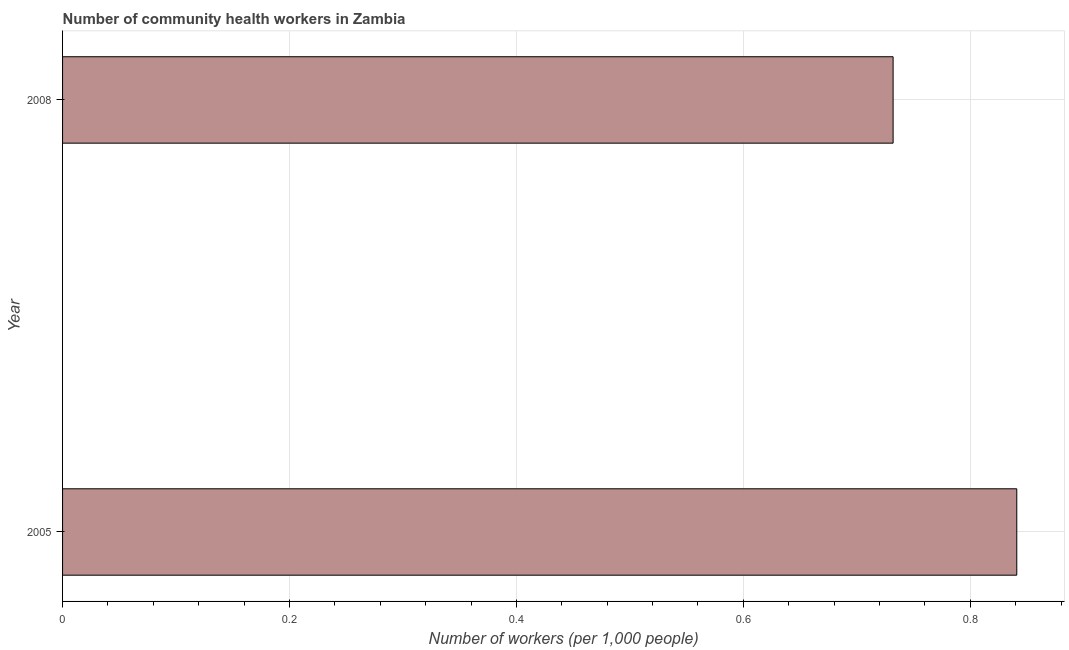What is the title of the graph?
Your answer should be very brief. Number of community health workers in Zambia. What is the label or title of the X-axis?
Your answer should be very brief. Number of workers (per 1,0 people). What is the number of community health workers in 2008?
Give a very brief answer. 0.73. Across all years, what is the maximum number of community health workers?
Offer a terse response. 0.84. Across all years, what is the minimum number of community health workers?
Your response must be concise. 0.73. In which year was the number of community health workers maximum?
Keep it short and to the point. 2005. What is the sum of the number of community health workers?
Give a very brief answer. 1.57. What is the difference between the number of community health workers in 2005 and 2008?
Keep it short and to the point. 0.11. What is the average number of community health workers per year?
Provide a succinct answer. 0.79. What is the median number of community health workers?
Provide a short and direct response. 0.79. What is the ratio of the number of community health workers in 2005 to that in 2008?
Provide a succinct answer. 1.15. Is the number of community health workers in 2005 less than that in 2008?
Provide a succinct answer. No. Are all the bars in the graph horizontal?
Ensure brevity in your answer.  Yes. Are the values on the major ticks of X-axis written in scientific E-notation?
Make the answer very short. No. What is the Number of workers (per 1,000 people) in 2005?
Your response must be concise. 0.84. What is the Number of workers (per 1,000 people) in 2008?
Your answer should be very brief. 0.73. What is the difference between the Number of workers (per 1,000 people) in 2005 and 2008?
Your answer should be compact. 0.11. What is the ratio of the Number of workers (per 1,000 people) in 2005 to that in 2008?
Give a very brief answer. 1.15. 